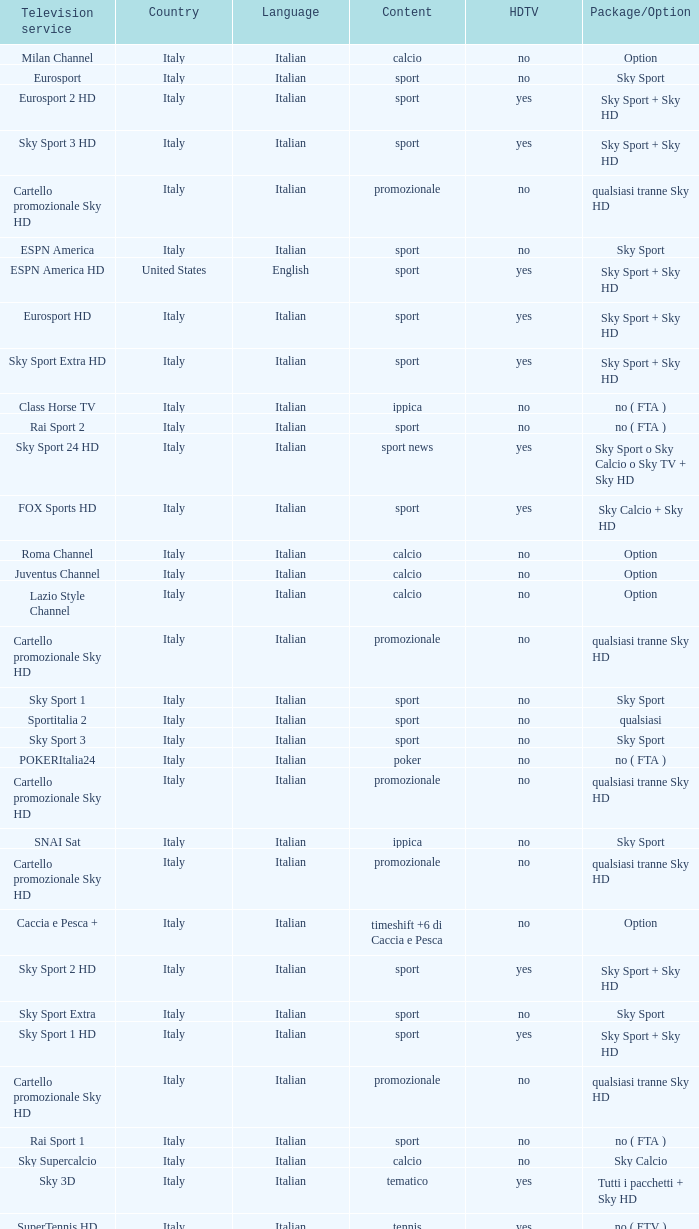What is Country, when Television Service is Eurosport 2? Italy. 